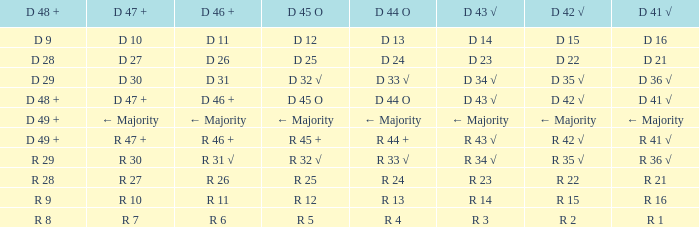When the value of d 44 o is mainly negative, what is the value of d 45 o? ← Majority. Help me parse the entirety of this table. {'header': ['D 48 +', 'D 47 +', 'D 46 +', 'D 45 O', 'D 44 O', 'D 43 √', 'D 42 √', 'D 41 √'], 'rows': [['D 9', 'D 10', 'D 11', 'D 12', 'D 13', 'D 14', 'D 15', 'D 16'], ['D 28', 'D 27', 'D 26', 'D 25', 'D 24', 'D 23', 'D 22', 'D 21'], ['D 29', 'D 30', 'D 31', 'D 32 √', 'D 33 √', 'D 34 √', 'D 35 √', 'D 36 √'], ['D 48 +', 'D 47 +', 'D 46 +', 'D 45 O', 'D 44 O', 'D 43 √', 'D 42 √', 'D 41 √'], ['D 49 +', '← Majority', '← Majority', '← Majority', '← Majority', '← Majority', '← Majority', '← Majority'], ['D 49 +', 'R 47 +', 'R 46 +', 'R 45 +', 'R 44 +', 'R 43 √', 'R 42 √', 'R 41 √'], ['R 29', 'R 30', 'R 31 √', 'R 32 √', 'R 33 √', 'R 34 √', 'R 35 √', 'R 36 √'], ['R 28', 'R 27', 'R 26', 'R 25', 'R 24', 'R 23', 'R 22', 'R 21'], ['R 9', 'R 10', 'R 11', 'R 12', 'R 13', 'R 14', 'R 15', 'R 16'], ['R 8', 'R 7', 'R 6', 'R 5', 'R 4', 'R 3', 'R 2', 'R 1']]} 